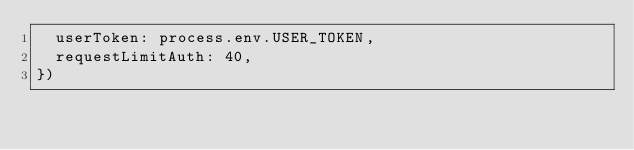<code> <loc_0><loc_0><loc_500><loc_500><_JavaScript_>  userToken: process.env.USER_TOKEN,
  requestLimitAuth: 40,
})
</code> 